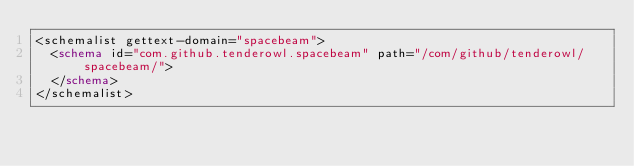Convert code to text. <code><loc_0><loc_0><loc_500><loc_500><_XML_><schemalist gettext-domain="spacebeam">
	<schema id="com.github.tenderowl.spacebeam" path="/com/github/tenderowl/spacebeam/">
	</schema>
</schemalist>
</code> 